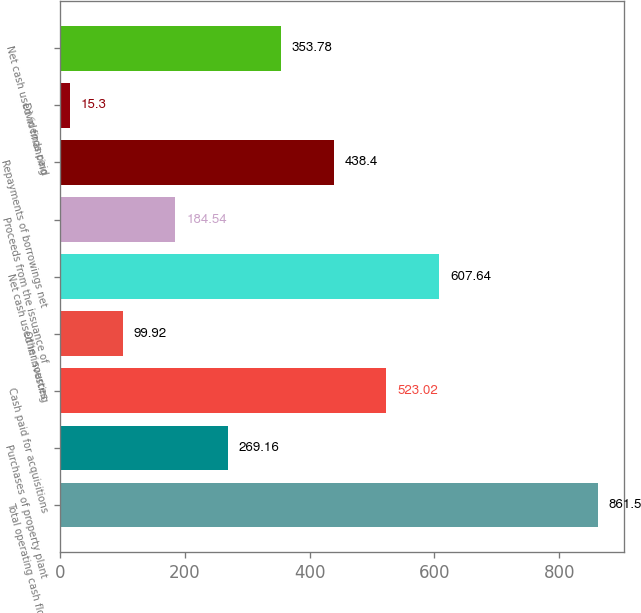<chart> <loc_0><loc_0><loc_500><loc_500><bar_chart><fcel>Total operating cash flows<fcel>Purchases of property plant<fcel>Cash paid for acquisitions<fcel>Other sources<fcel>Net cash used in investing<fcel>Proceeds from the issuance of<fcel>Repayments of borrowings net<fcel>Dividends paid<fcel>Net cash used in financing<nl><fcel>861.5<fcel>269.16<fcel>523.02<fcel>99.92<fcel>607.64<fcel>184.54<fcel>438.4<fcel>15.3<fcel>353.78<nl></chart> 